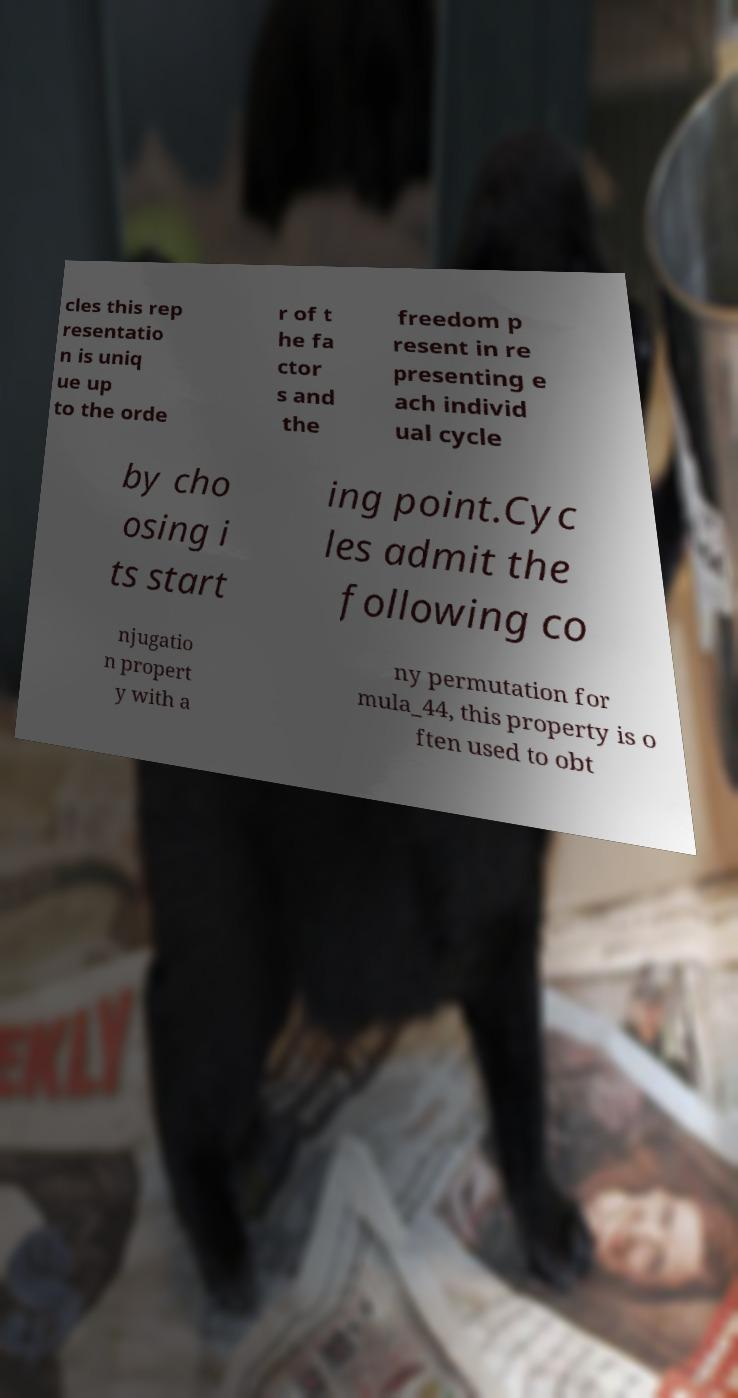Please identify and transcribe the text found in this image. cles this rep resentatio n is uniq ue up to the orde r of t he fa ctor s and the freedom p resent in re presenting e ach individ ual cycle by cho osing i ts start ing point.Cyc les admit the following co njugatio n propert y with a ny permutation for mula_44, this property is o ften used to obt 